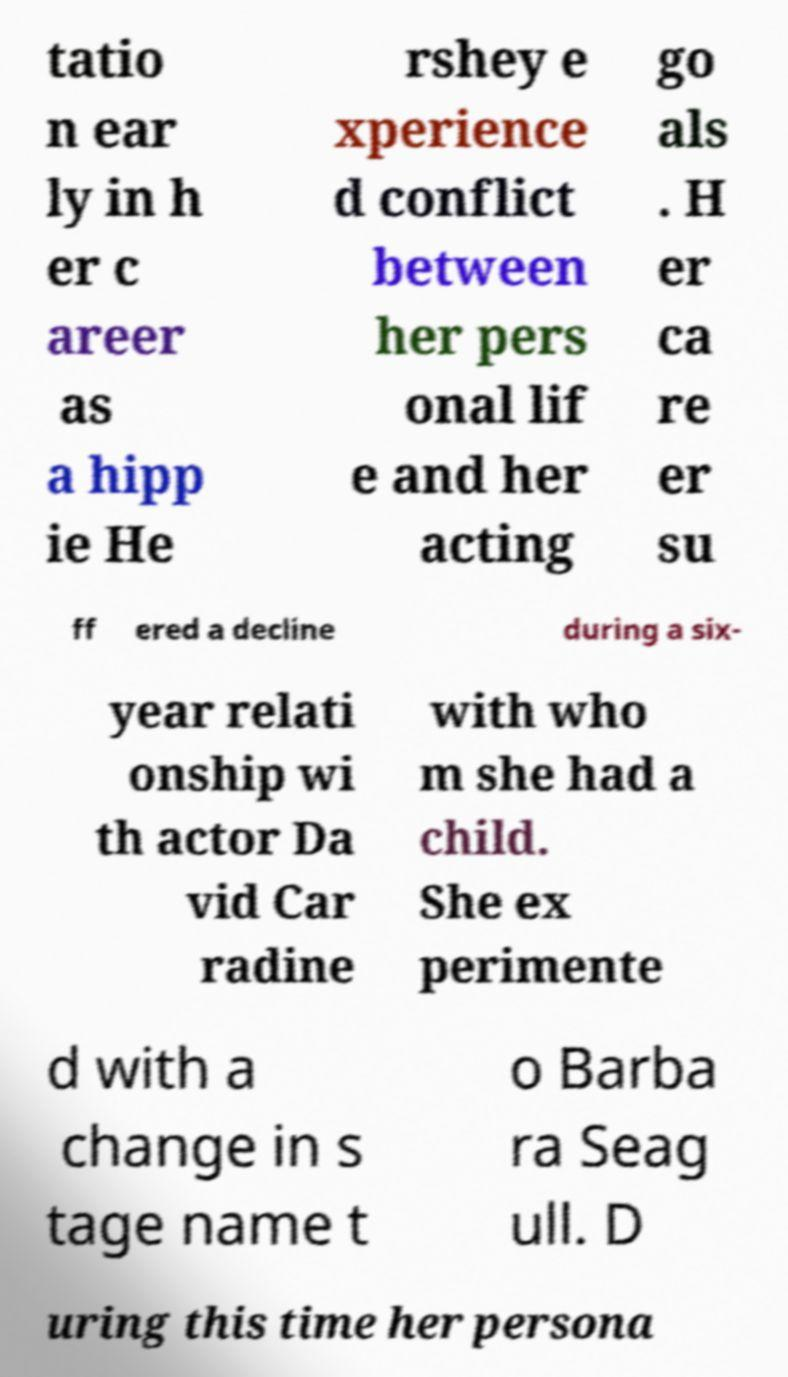Can you read and provide the text displayed in the image?This photo seems to have some interesting text. Can you extract and type it out for me? tatio n ear ly in h er c areer as a hipp ie He rshey e xperience d conflict between her pers onal lif e and her acting go als . H er ca re er su ff ered a decline during a six- year relati onship wi th actor Da vid Car radine with who m she had a child. She ex perimente d with a change in s tage name t o Barba ra Seag ull. D uring this time her persona 